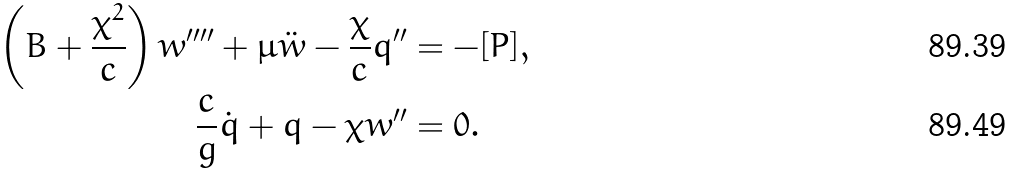<formula> <loc_0><loc_0><loc_500><loc_500>\left ( B + \frac { \chi ^ { 2 } } { c } \right ) w ^ { \prime \prime \prime \prime } + \mu \ddot { w } - \frac { \chi } { c } q ^ { \prime \prime } & = - [ P ] , \\ \frac { c } { g } \dot { q } + q - \chi w ^ { \prime \prime } & = 0 .</formula> 